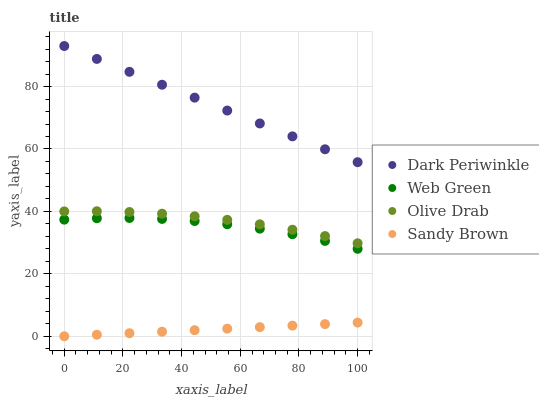Does Sandy Brown have the minimum area under the curve?
Answer yes or no. Yes. Does Dark Periwinkle have the maximum area under the curve?
Answer yes or no. Yes. Does Dark Periwinkle have the minimum area under the curve?
Answer yes or no. No. Does Sandy Brown have the maximum area under the curve?
Answer yes or no. No. Is Sandy Brown the smoothest?
Answer yes or no. Yes. Is Web Green the roughest?
Answer yes or no. Yes. Is Dark Periwinkle the smoothest?
Answer yes or no. No. Is Dark Periwinkle the roughest?
Answer yes or no. No. Does Sandy Brown have the lowest value?
Answer yes or no. Yes. Does Dark Periwinkle have the lowest value?
Answer yes or no. No. Does Dark Periwinkle have the highest value?
Answer yes or no. Yes. Does Sandy Brown have the highest value?
Answer yes or no. No. Is Web Green less than Dark Periwinkle?
Answer yes or no. Yes. Is Dark Periwinkle greater than Web Green?
Answer yes or no. Yes. Does Web Green intersect Dark Periwinkle?
Answer yes or no. No. 